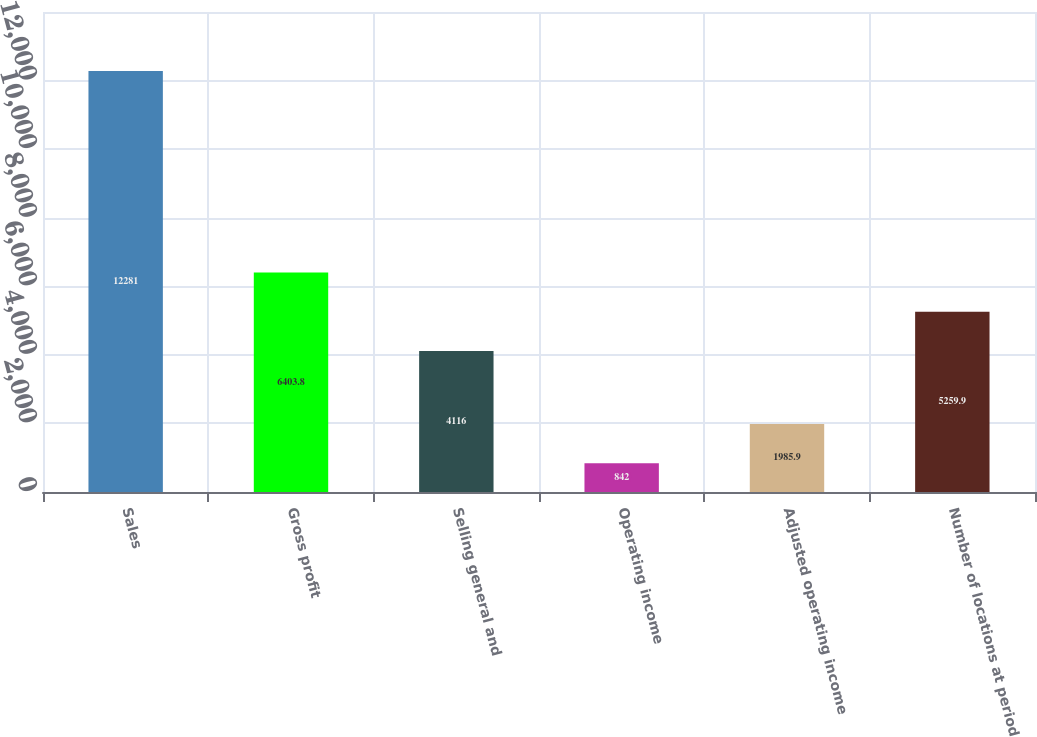Convert chart. <chart><loc_0><loc_0><loc_500><loc_500><bar_chart><fcel>Sales<fcel>Gross profit<fcel>Selling general and<fcel>Operating income<fcel>Adjusted operating income<fcel>Number of locations at period<nl><fcel>12281<fcel>6403.8<fcel>4116<fcel>842<fcel>1985.9<fcel>5259.9<nl></chart> 